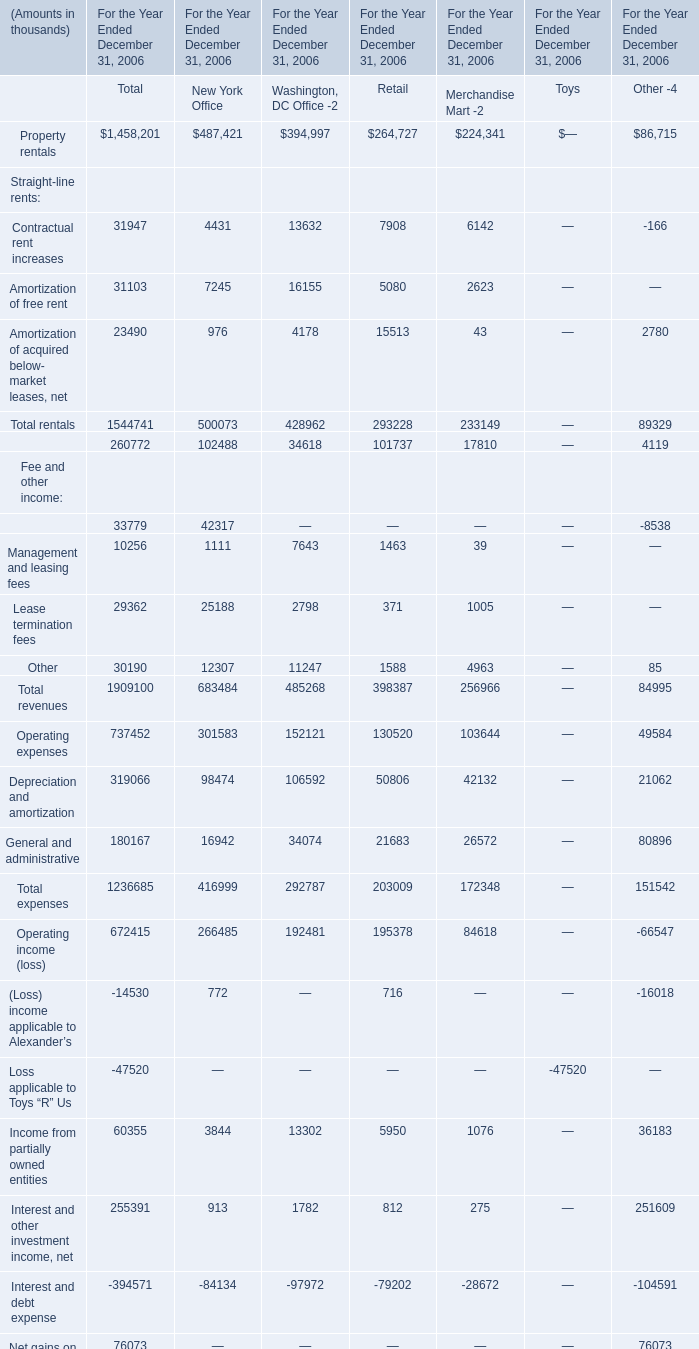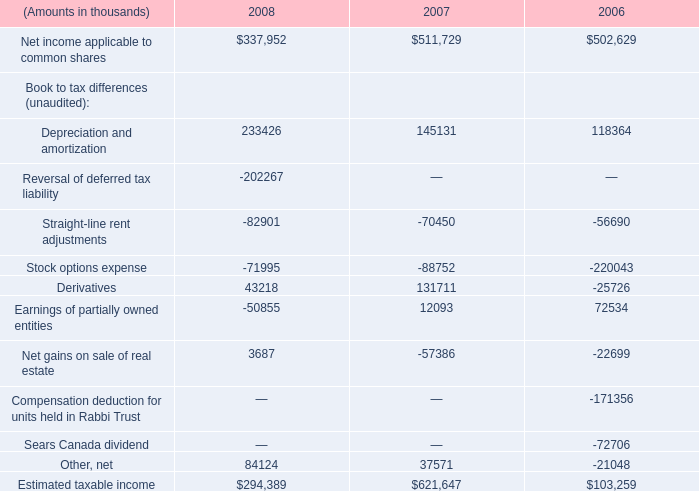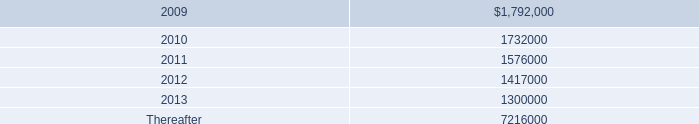What is the difference between New York Office and Retail 's highest Straight-line rents? (in thousand) 
Computations: (500073 - 293228)
Answer: 206845.0. 